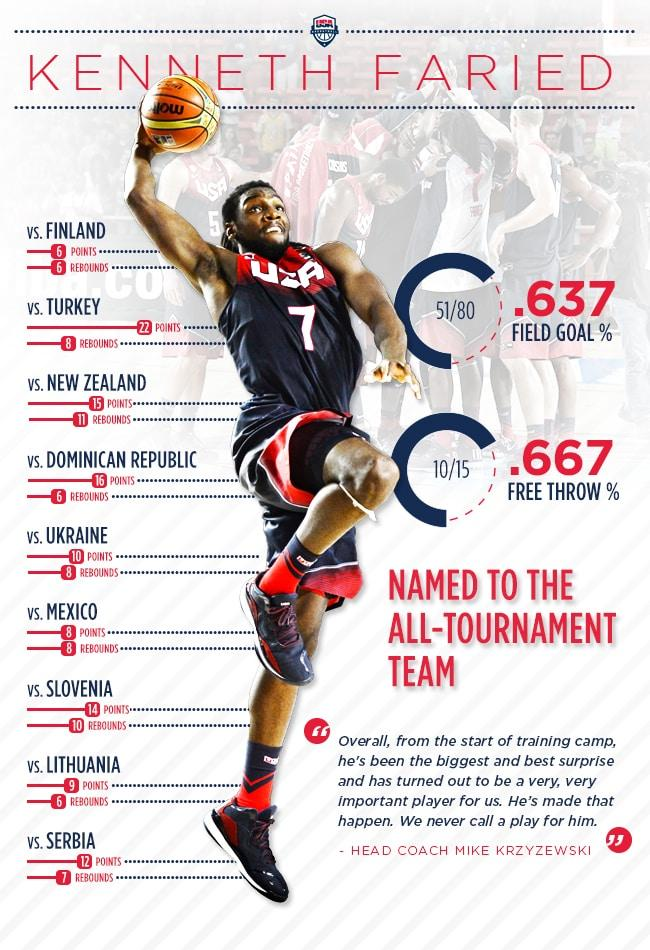Mention a couple of crucial points in this snapshot. The total points scored by Faried in the match against Serbia and Ukraine was 22. Faried scored the highest number of rebounds against Slovenia, among all the countries he has played against. Club USA has played with 9 different countries. Faried scored a total of 22 points in a game. Kenneth Faried currently plays for the USA Basketball team, which is not a professional club. 